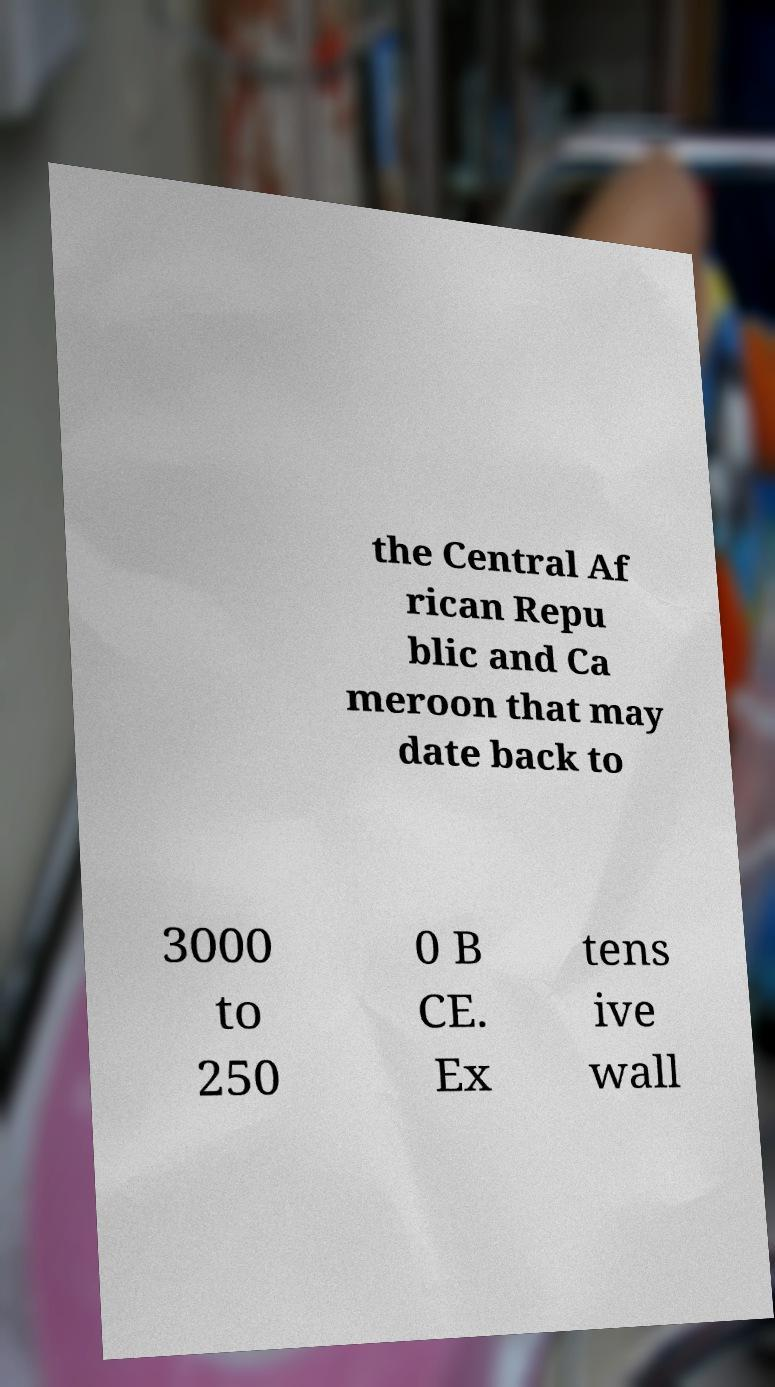Can you read and provide the text displayed in the image?This photo seems to have some interesting text. Can you extract and type it out for me? the Central Af rican Repu blic and Ca meroon that may date back to 3000 to 250 0 B CE. Ex tens ive wall 